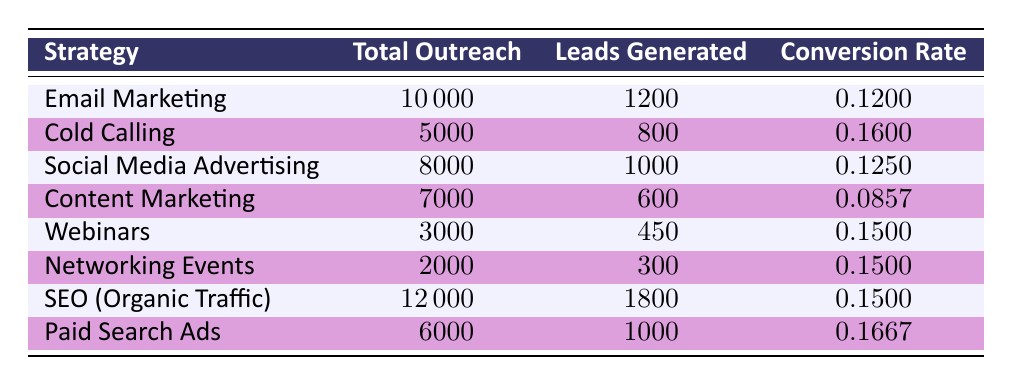What was the total outreach for the "SEO (Organic Traffic)" strategy? The value for total outreach for "SEO (Organic Traffic)" can be directly obtained from the table where it lists 12000 for this strategy.
Answer: 12000 What is the conversion rate for "Cold Calling"? The conversion rate for "Cold Calling" is listed directly in the table as 0.1600.
Answer: 0.1600 Which outreach strategy generated the most leads? By comparing the leads generated across all strategies, "SEO (Organic Traffic)" with 1800 leads generated stands out as the highest, confirming it as the strategy with the most leads.
Answer: SEO (Organic Traffic) Is the conversion rate for "Content Marketing" higher than 0.1? The conversion rate for "Content Marketing" is reported as 0.0857 in the table, which is below 0.1, therefore the statement is false.
Answer: No What is the average conversion rate for all strategies listed in the table? To find the average conversion rate, we sum up all conversion rates: (0.12 + 0.16 + 0.125 + 0.0857 + 0.15 + 0.15 + 0.15 + 0.1667) = 1.1374. Then, divide by the number of strategies (8): 1.1374 / 8 = 0.142175, rounded to four decimal places gives 0.1422.
Answer: 0.1422 Which strategy has the lowest total outreach? A quick glance at the total outreach numbers shows that "Networking Events" has the lowest outreach at 2000.
Answer: Networking Events What is the difference in leads generated between "Email Marketing" and "Paid Search Ads"? "Email Marketing" generated 1200 leads while "Paid Search Ads" generated 1000 leads. The difference is calculated as 1200 - 1000 = 200.
Answer: 200 Can we conclude that "Webinars" and "Networking Events" have the same conversion rate? By comparing the conversion rates in the table, both "Webinars" and "Networking Events" have a conversion rate of 0.15. Thus, we confirm the statement is true.
Answer: Yes 